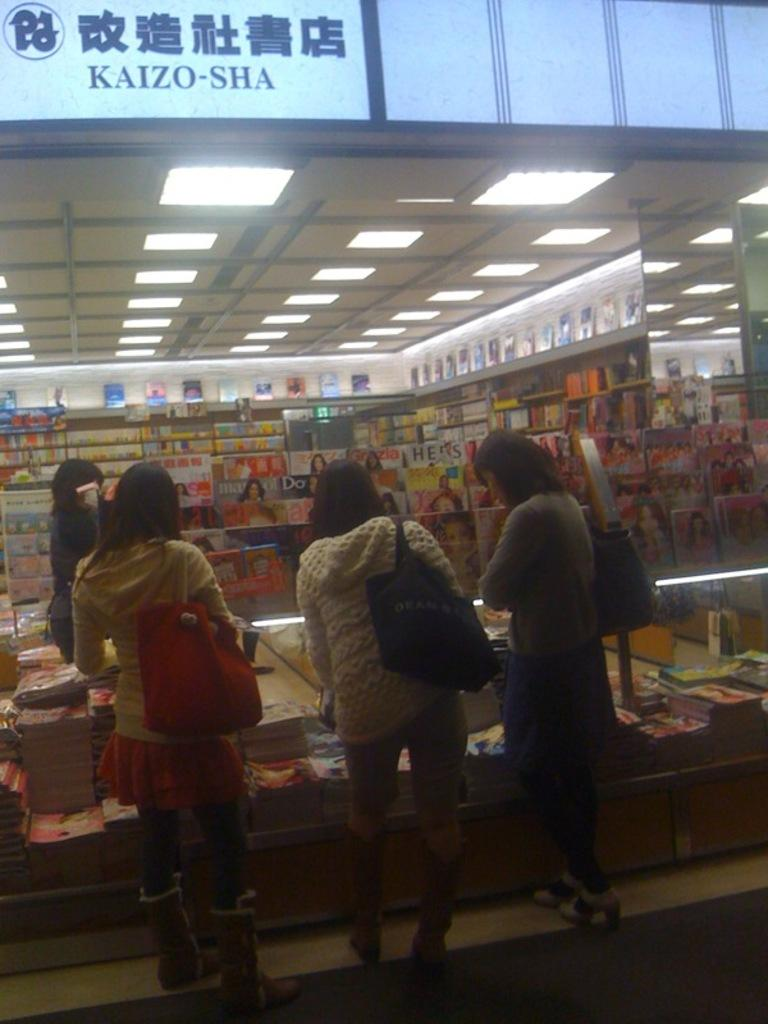<image>
Summarize the visual content of the image. Three women looking at a magazine rack in front of the Kaizo-Sha bookstore. 